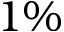Convert formula to latex. <formula><loc_0><loc_0><loc_500><loc_500>1 \%</formula> 